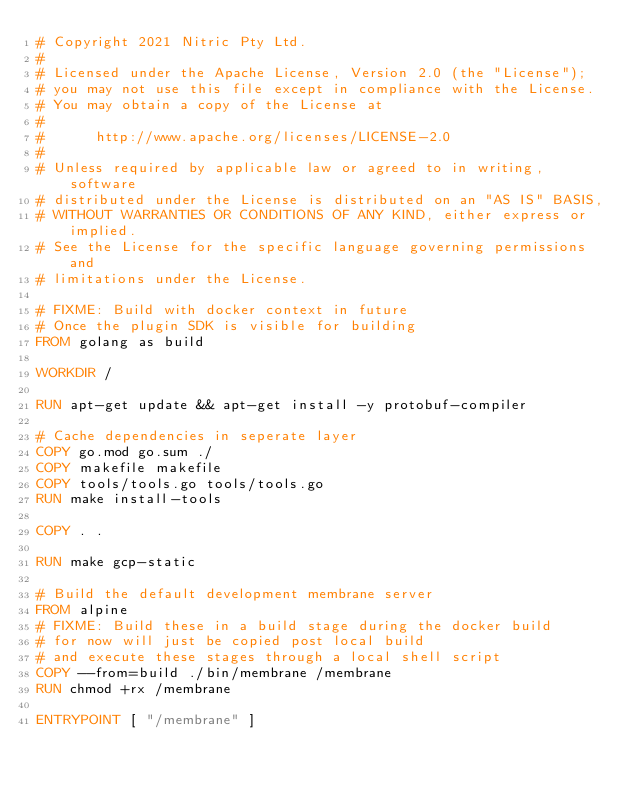<code> <loc_0><loc_0><loc_500><loc_500><_Dockerfile_># Copyright 2021 Nitric Pty Ltd.
#
# Licensed under the Apache License, Version 2.0 (the "License");
# you may not use this file except in compliance with the License.
# You may obtain a copy of the License at
#
#      http://www.apache.org/licenses/LICENSE-2.0
#
# Unless required by applicable law or agreed to in writing, software
# distributed under the License is distributed on an "AS IS" BASIS,
# WITHOUT WARRANTIES OR CONDITIONS OF ANY KIND, either express or implied.
# See the License for the specific language governing permissions and
# limitations under the License.

# FIXME: Build with docker context in future
# Once the plugin SDK is visible for building
FROM golang as build

WORKDIR /

RUN apt-get update && apt-get install -y protobuf-compiler

# Cache dependencies in seperate layer
COPY go.mod go.sum ./
COPY makefile makefile
COPY tools/tools.go tools/tools.go
RUN make install-tools

COPY . .

RUN make gcp-static

# Build the default development membrane server
FROM alpine
# FIXME: Build these in a build stage during the docker build
# for now will just be copied post local build
# and execute these stages through a local shell script
COPY --from=build ./bin/membrane /membrane
RUN chmod +rx /membrane

ENTRYPOINT [ "/membrane" ]</code> 